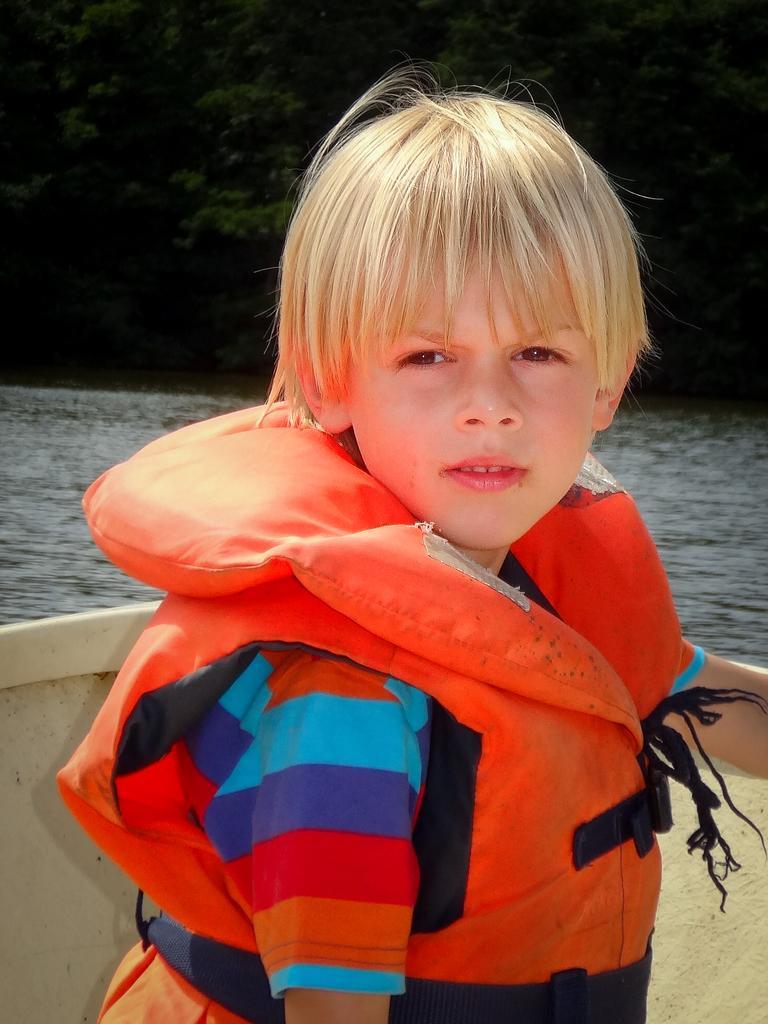Please provide a concise description of this image. In this picture, there is a boy sitting on a boat. He is wearing an orange jacket. In the background, there is water and trees. 